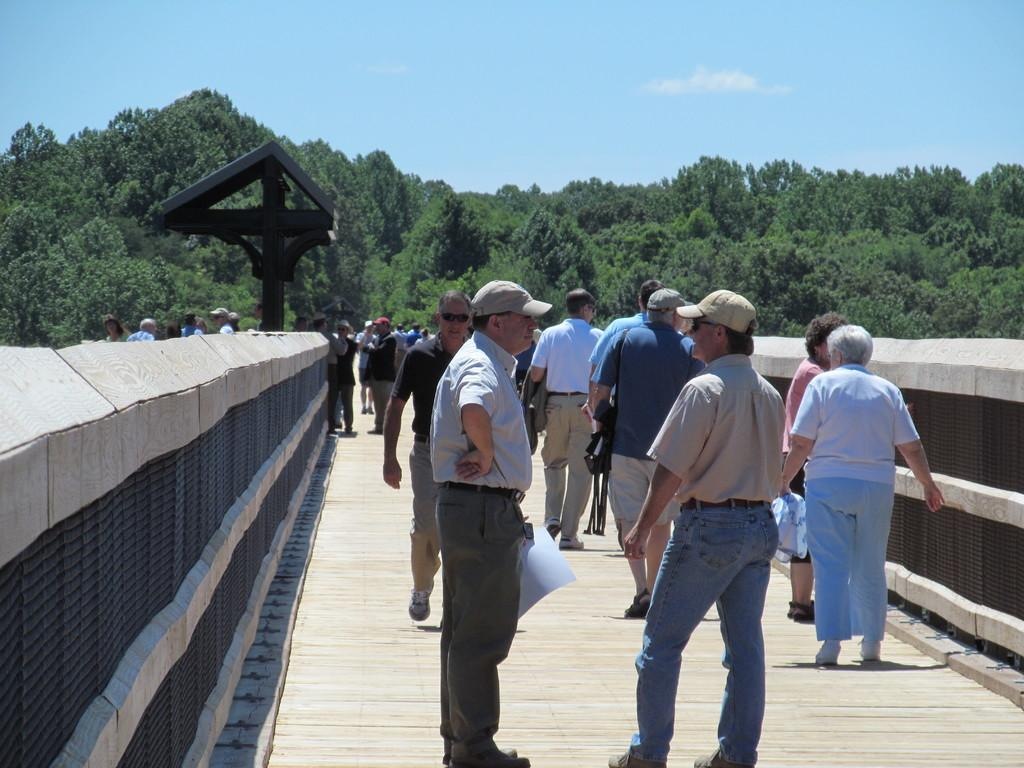What are the people in the image doing? The people in the image are standing in the center and holding objects. What can be seen in the background of the image? Sky, clouds, trees, and a bridge are visible in the background of the image. How many objects are the people holding? The number of objects the people are holding cannot be determined from the provided facts. What type of protest is being held by the people in the image? There is no protest present in the image; the people are simply standing and holding objects. 